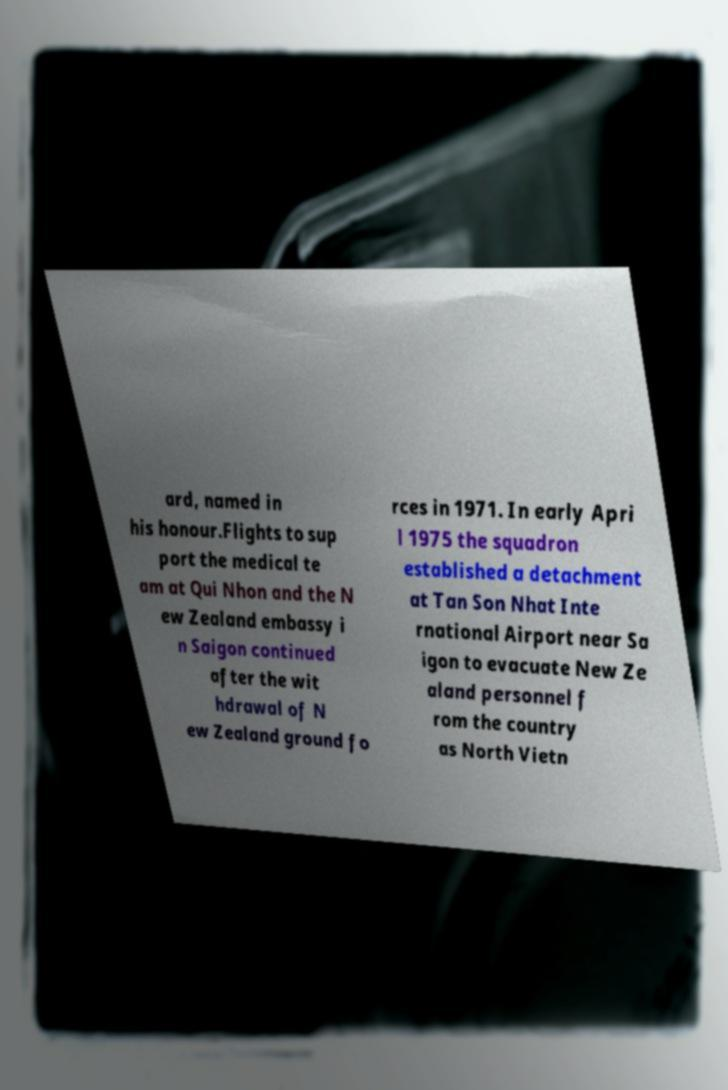Can you accurately transcribe the text from the provided image for me? ard, named in his honour.Flights to sup port the medical te am at Qui Nhon and the N ew Zealand embassy i n Saigon continued after the wit hdrawal of N ew Zealand ground fo rces in 1971. In early Apri l 1975 the squadron established a detachment at Tan Son Nhat Inte rnational Airport near Sa igon to evacuate New Ze aland personnel f rom the country as North Vietn 